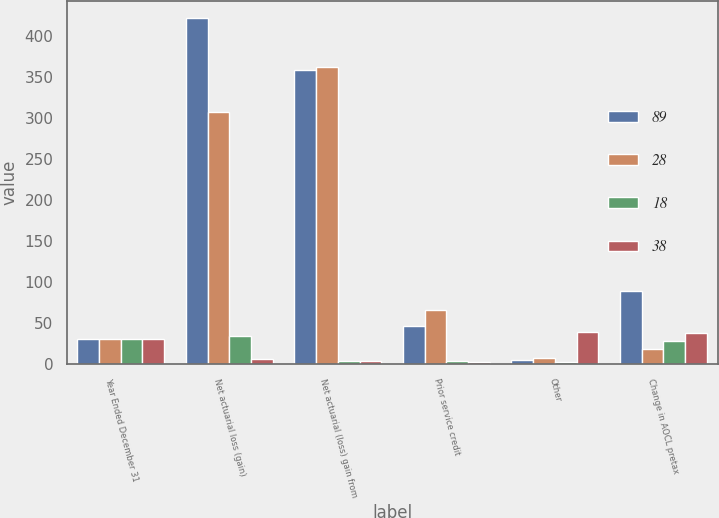<chart> <loc_0><loc_0><loc_500><loc_500><stacked_bar_chart><ecel><fcel>Year Ended December 31<fcel>Net actuarial loss (gain)<fcel>Net actuarial (loss) gain from<fcel>Prior service credit<fcel>Other<fcel>Change in AOCL pretax<nl><fcel>89<fcel>31<fcel>422<fcel>359<fcel>46<fcel>5<fcel>89<nl><fcel>28<fcel>31<fcel>308<fcel>362<fcel>66<fcel>7<fcel>18<nl><fcel>18<fcel>31<fcel>34<fcel>4<fcel>4<fcel>2<fcel>28<nl><fcel>38<fcel>31<fcel>6<fcel>4<fcel>3<fcel>39<fcel>38<nl></chart> 